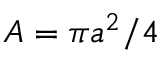Convert formula to latex. <formula><loc_0><loc_0><loc_500><loc_500>A = \pi a ^ { 2 } / 4</formula> 